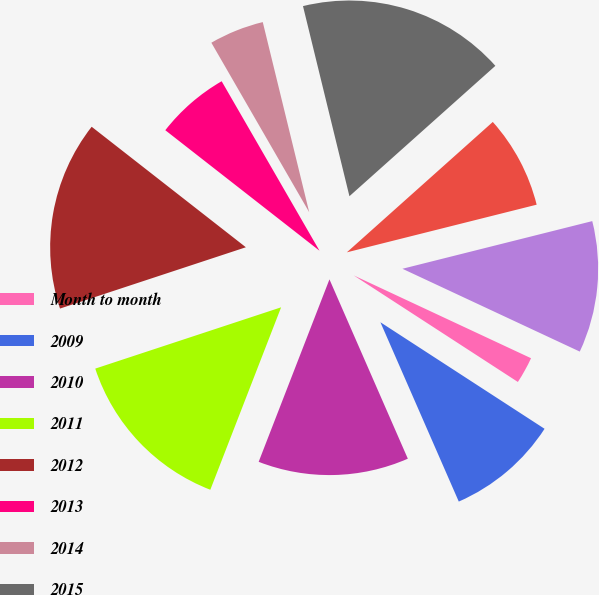Convert chart. <chart><loc_0><loc_0><loc_500><loc_500><pie_chart><fcel>Month to month<fcel>2009<fcel>2010<fcel>2011<fcel>2012<fcel>2013<fcel>2014<fcel>2015<fcel>2016<fcel>2017<nl><fcel>2.21%<fcel>9.28%<fcel>12.45%<fcel>14.04%<fcel>15.63%<fcel>6.11%<fcel>4.52%<fcel>17.21%<fcel>7.69%<fcel>10.87%<nl></chart> 